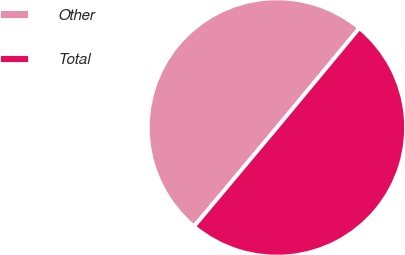Convert chart. <chart><loc_0><loc_0><loc_500><loc_500><pie_chart><fcel>Other<fcel>Total<nl><fcel>49.92%<fcel>50.08%<nl></chart> 